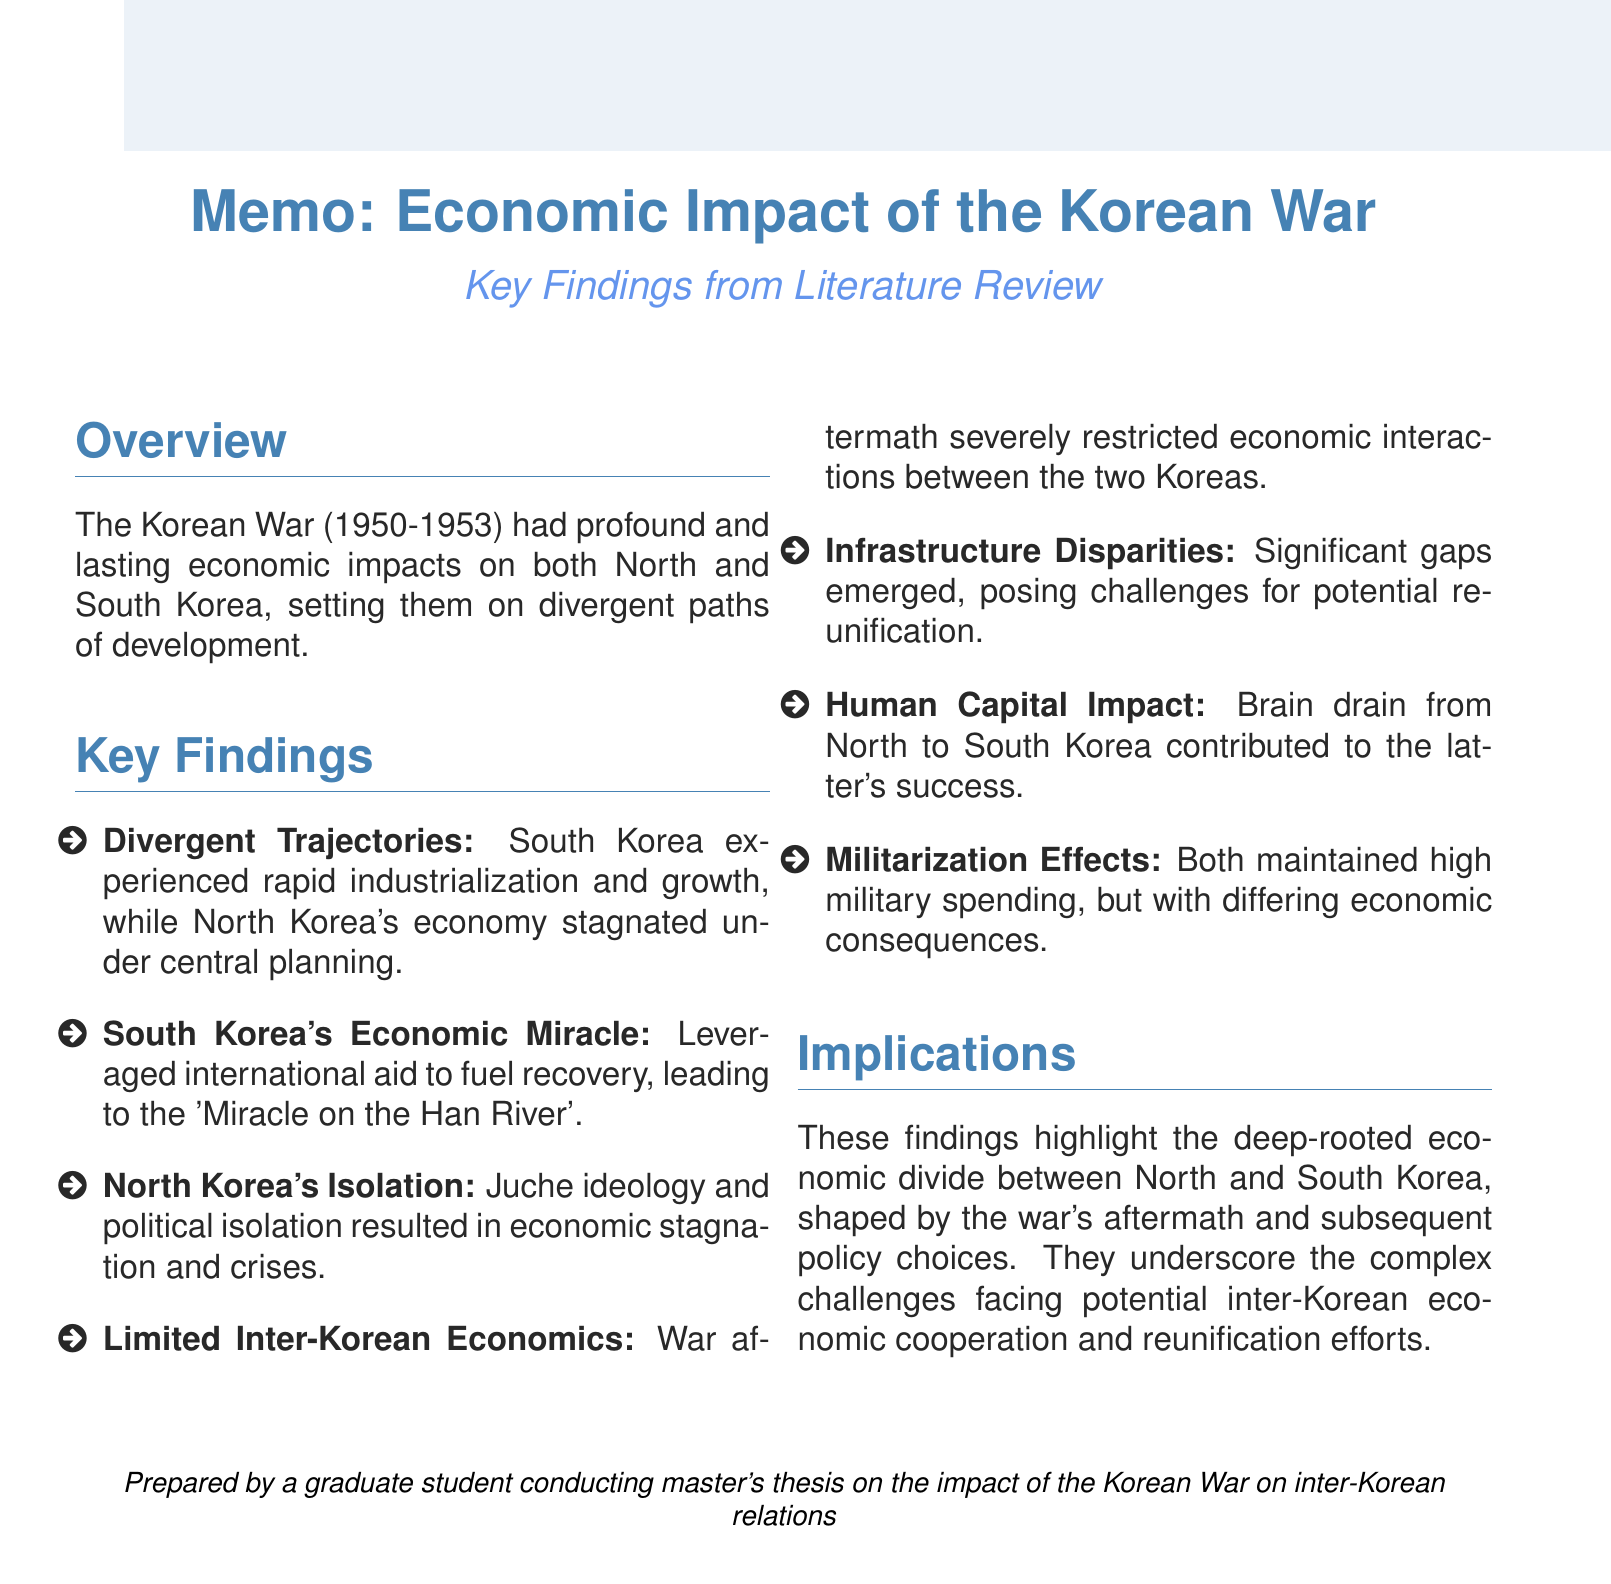what are the diverging economic paths of North and South Korea? The North's economy stagnated under a centrally planned system, while South Korea experienced rapid industrialization and economic growth.
Answer: stagnated; rapid industrialization what international aid did South Korea leverage for recovery? The document states that South Korea particularly leveraged aid from the United States.
Answer: United States what ideology contributed to North Korea's economic struggles? The Juche ideology focused on self-reliance and political isolation, leading to economic stagnation.
Answer: Juche what significant infrastructure issue arose from the war? The war's destruction led to significant infrastructure gaps, posing challenges for reunification.
Answer: infrastructure gaps what phenomenon contributed to South Korea's economic success post-war? A notable impact was the brain drain from North to South Korea.
Answer: brain drain what was a key economic initiative launched between the two Koreas in 2004? The Kaesong Industrial Complex represented a rare instance of economic cooperation.
Answer: Kaesong Industrial Complex how did military spending differ between the two Koreas after the war? South Korea balanced military needs with economic development, while North Korea's policy diverted resources from civilian sectors.
Answer: differing economic consequences what is a major challenge for potential reunification efforts? Significant infrastructure disparities between North and South Korea pose a major challenge.
Answer: infrastructure disparities 